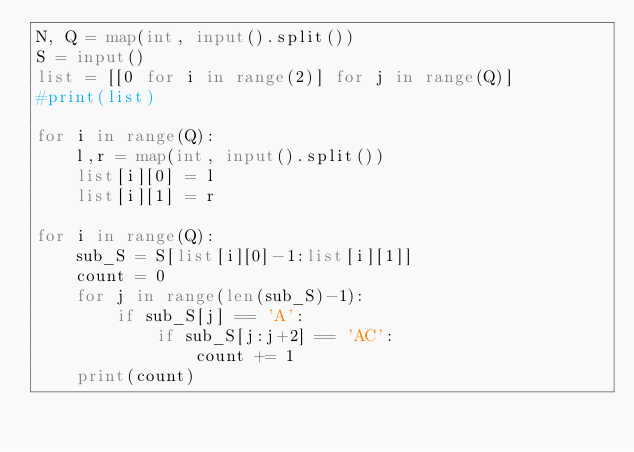<code> <loc_0><loc_0><loc_500><loc_500><_Python_>N, Q = map(int, input().split())
S = input()
list = [[0 for i in range(2)] for j in range(Q)]
#print(list)

for i in range(Q):
    l,r = map(int, input().split())
    list[i][0] = l
    list[i][1] = r

for i in range(Q):
    sub_S = S[list[i][0]-1:list[i][1]]
    count = 0
    for j in range(len(sub_S)-1):
        if sub_S[j] == 'A':
            if sub_S[j:j+2] == 'AC':
                count += 1
    print(count)</code> 